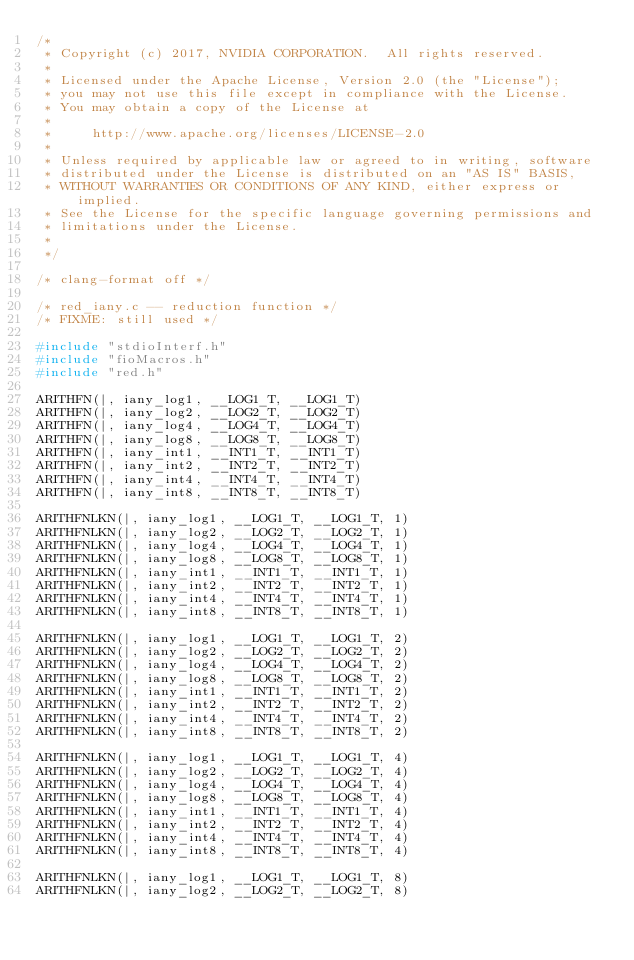<code> <loc_0><loc_0><loc_500><loc_500><_C_>/*
 * Copyright (c) 2017, NVIDIA CORPORATION.  All rights reserved.
 *
 * Licensed under the Apache License, Version 2.0 (the "License");
 * you may not use this file except in compliance with the License.
 * You may obtain a copy of the License at
 *
 *     http://www.apache.org/licenses/LICENSE-2.0
 *
 * Unless required by applicable law or agreed to in writing, software
 * distributed under the License is distributed on an "AS IS" BASIS,
 * WITHOUT WARRANTIES OR CONDITIONS OF ANY KIND, either express or implied.
 * See the License for the specific language governing permissions and
 * limitations under the License.
 *
 */

/* clang-format off */

/* red_iany.c -- reduction function */
/* FIXME: still used */

#include "stdioInterf.h"
#include "fioMacros.h"
#include "red.h"

ARITHFN(|, iany_log1, __LOG1_T, __LOG1_T)
ARITHFN(|, iany_log2, __LOG2_T, __LOG2_T)
ARITHFN(|, iany_log4, __LOG4_T, __LOG4_T)
ARITHFN(|, iany_log8, __LOG8_T, __LOG8_T)
ARITHFN(|, iany_int1, __INT1_T, __INT1_T)
ARITHFN(|, iany_int2, __INT2_T, __INT2_T)
ARITHFN(|, iany_int4, __INT4_T, __INT4_T)
ARITHFN(|, iany_int8, __INT8_T, __INT8_T)

ARITHFNLKN(|, iany_log1, __LOG1_T, __LOG1_T, 1)
ARITHFNLKN(|, iany_log2, __LOG2_T, __LOG2_T, 1)
ARITHFNLKN(|, iany_log4, __LOG4_T, __LOG4_T, 1)
ARITHFNLKN(|, iany_log8, __LOG8_T, __LOG8_T, 1)
ARITHFNLKN(|, iany_int1, __INT1_T, __INT1_T, 1)
ARITHFNLKN(|, iany_int2, __INT2_T, __INT2_T, 1)
ARITHFNLKN(|, iany_int4, __INT4_T, __INT4_T, 1)
ARITHFNLKN(|, iany_int8, __INT8_T, __INT8_T, 1)

ARITHFNLKN(|, iany_log1, __LOG1_T, __LOG1_T, 2)
ARITHFNLKN(|, iany_log2, __LOG2_T, __LOG2_T, 2)
ARITHFNLKN(|, iany_log4, __LOG4_T, __LOG4_T, 2)
ARITHFNLKN(|, iany_log8, __LOG8_T, __LOG8_T, 2)
ARITHFNLKN(|, iany_int1, __INT1_T, __INT1_T, 2)
ARITHFNLKN(|, iany_int2, __INT2_T, __INT2_T, 2)
ARITHFNLKN(|, iany_int4, __INT4_T, __INT4_T, 2)
ARITHFNLKN(|, iany_int8, __INT8_T, __INT8_T, 2)

ARITHFNLKN(|, iany_log1, __LOG1_T, __LOG1_T, 4)
ARITHFNLKN(|, iany_log2, __LOG2_T, __LOG2_T, 4)
ARITHFNLKN(|, iany_log4, __LOG4_T, __LOG4_T, 4)
ARITHFNLKN(|, iany_log8, __LOG8_T, __LOG8_T, 4)
ARITHFNLKN(|, iany_int1, __INT1_T, __INT1_T, 4)
ARITHFNLKN(|, iany_int2, __INT2_T, __INT2_T, 4)
ARITHFNLKN(|, iany_int4, __INT4_T, __INT4_T, 4)
ARITHFNLKN(|, iany_int8, __INT8_T, __INT8_T, 4)

ARITHFNLKN(|, iany_log1, __LOG1_T, __LOG1_T, 8)
ARITHFNLKN(|, iany_log2, __LOG2_T, __LOG2_T, 8)</code> 